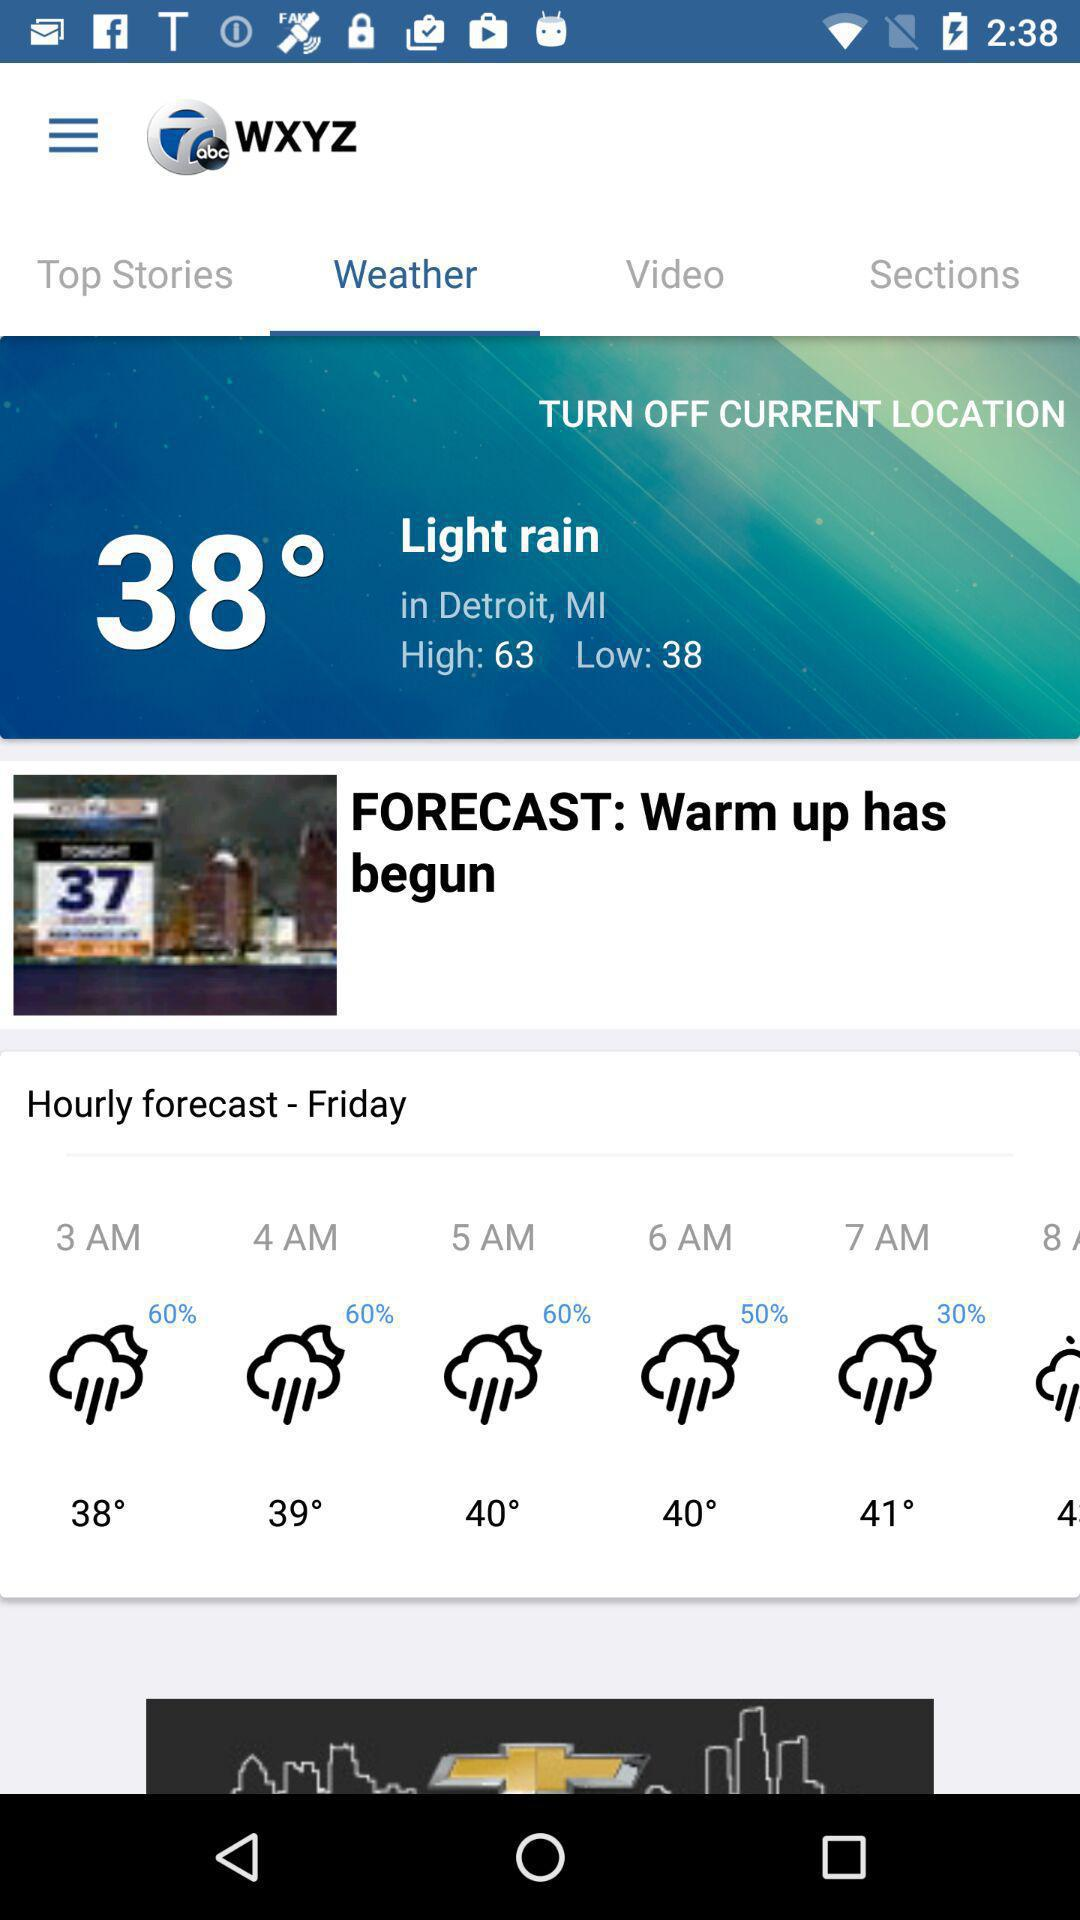How many degrees warmer is the high temperature than the low temperature?
Answer the question using a single word or phrase. 25 